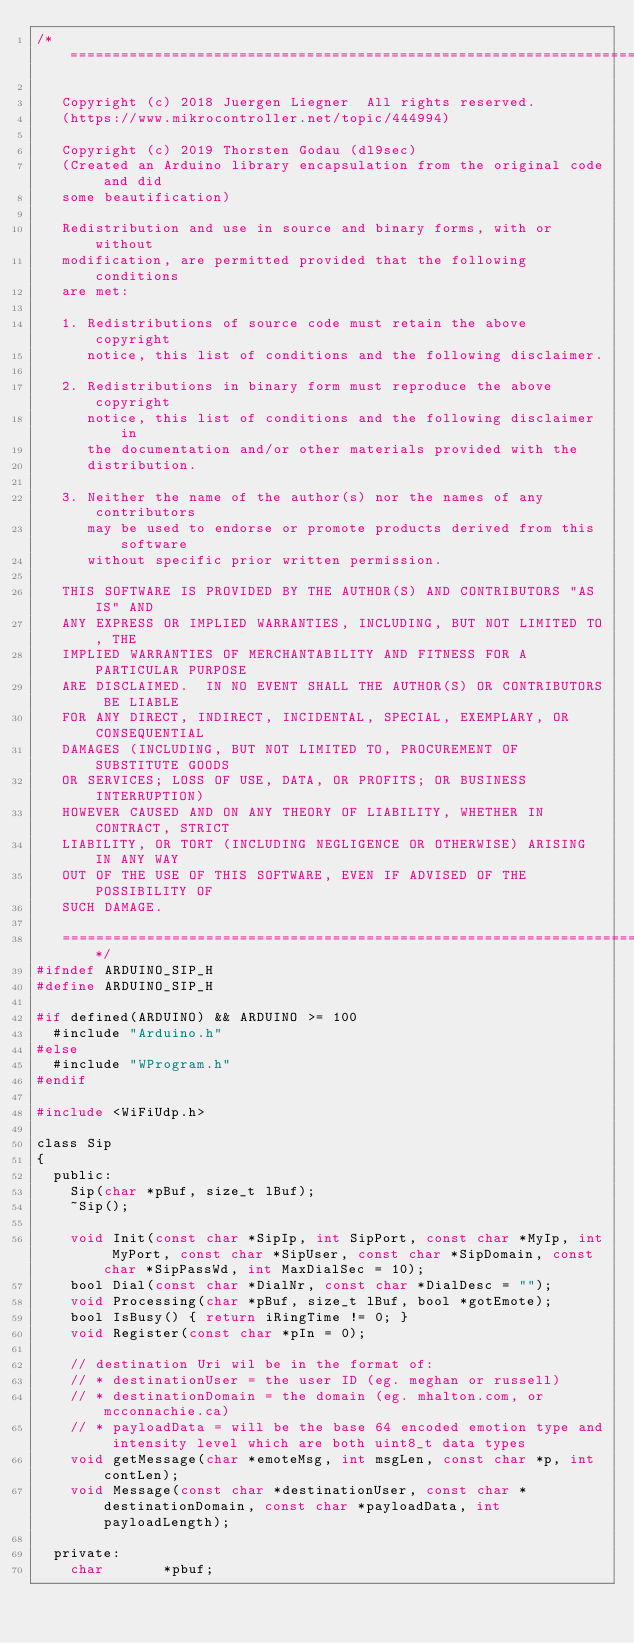<code> <loc_0><loc_0><loc_500><loc_500><_C_>/* ====================================================================

   Copyright (c) 2018 Juergen Liegner  All rights reserved.
   (https://www.mikrocontroller.net/topic/444994)

   Copyright (c) 2019 Thorsten Godau (dl9sec)
   (Created an Arduino library encapsulation from the original code and did
   some beautification)

   Redistribution and use in source and binary forms, with or without
   modification, are permitted provided that the following conditions
   are met:

   1. Redistributions of source code must retain the above copyright
      notice, this list of conditions and the following disclaimer.

   2. Redistributions in binary form must reproduce the above copyright
      notice, this list of conditions and the following disclaimer in
      the documentation and/or other materials provided with the
      distribution.

   3. Neither the name of the author(s) nor the names of any contributors
      may be used to endorse or promote products derived from this software
      without specific prior written permission.

   THIS SOFTWARE IS PROVIDED BY THE AUTHOR(S) AND CONTRIBUTORS "AS IS" AND
   ANY EXPRESS OR IMPLIED WARRANTIES, INCLUDING, BUT NOT LIMITED TO, THE
   IMPLIED WARRANTIES OF MERCHANTABILITY AND FITNESS FOR A PARTICULAR PURPOSE
   ARE DISCLAIMED.  IN NO EVENT SHALL THE AUTHOR(S) OR CONTRIBUTORS BE LIABLE
   FOR ANY DIRECT, INDIRECT, INCIDENTAL, SPECIAL, EXEMPLARY, OR CONSEQUENTIAL
   DAMAGES (INCLUDING, BUT NOT LIMITED TO, PROCUREMENT OF SUBSTITUTE GOODS
   OR SERVICES; LOSS OF USE, DATA, OR PROFITS; OR BUSINESS INTERRUPTION)
   HOWEVER CAUSED AND ON ANY THEORY OF LIABILITY, WHETHER IN CONTRACT, STRICT
   LIABILITY, OR TORT (INCLUDING NEGLIGENCE OR OTHERWISE) ARISING IN ANY WAY
   OUT OF THE USE OF THIS SOFTWARE, EVEN IF ADVISED OF THE POSSIBILITY OF
   SUCH DAMAGE.

   ====================================================================*/
#ifndef ARDUINO_SIP_H
#define ARDUINO_SIP_H

#if defined(ARDUINO) && ARDUINO >= 100
  #include "Arduino.h"
#else
  #include "WProgram.h"
#endif

#include <WiFiUdp.h>

class Sip
{
  public:
    Sip(char *pBuf, size_t lBuf);
    ~Sip();

    void Init(const char *SipIp, int SipPort, const char *MyIp, int MyPort, const char *SipUser, const char *SipDomain, const char *SipPassWd, int MaxDialSec = 10);
    bool Dial(const char *DialNr, const char *DialDesc = "");
    void Processing(char *pBuf, size_t lBuf, bool *gotEmote);
    bool IsBusy() { return iRingTime != 0; }
    void Register(const char *pIn = 0);

    // destination Uri wil be in the format of:
    // * destinationUser = the user ID (eg. meghan or russell)
    // * destinationDomain = the domain (eg. mhalton.com, or mcconnachie.ca)
    // * payloadData = will be the base 64 encoded emotion type and intensity level which are both uint8_t data types
    void getMessage(char *emoteMsg, int msgLen, const char *p, int contLen);
    void Message(const char *destinationUser, const char *destinationDomain, const char *payloadData, int payloadLength);

  private:
    char       *pbuf;</code> 